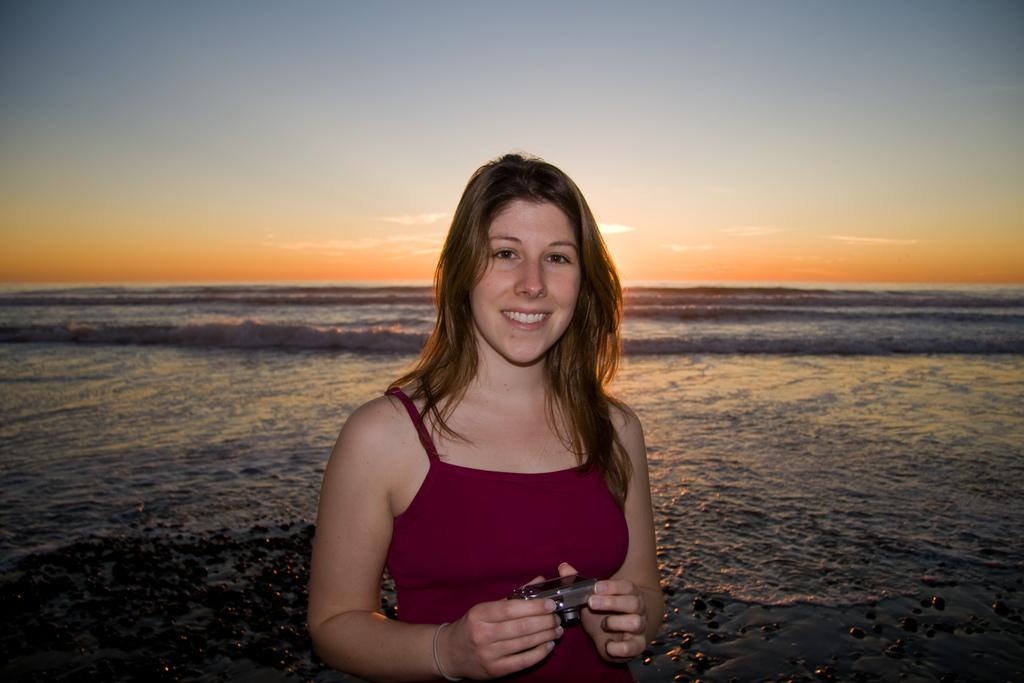What is the woman doing in the image? The woman is smiling in the image. What is the woman holding in the image? The woman is holding a camera in the image. What can be seen in the background of the image? There is water and the sky visible in the background of the image. How much money is the woman holding in the image? The woman is not holding any money in the image; she is holding a camera. 